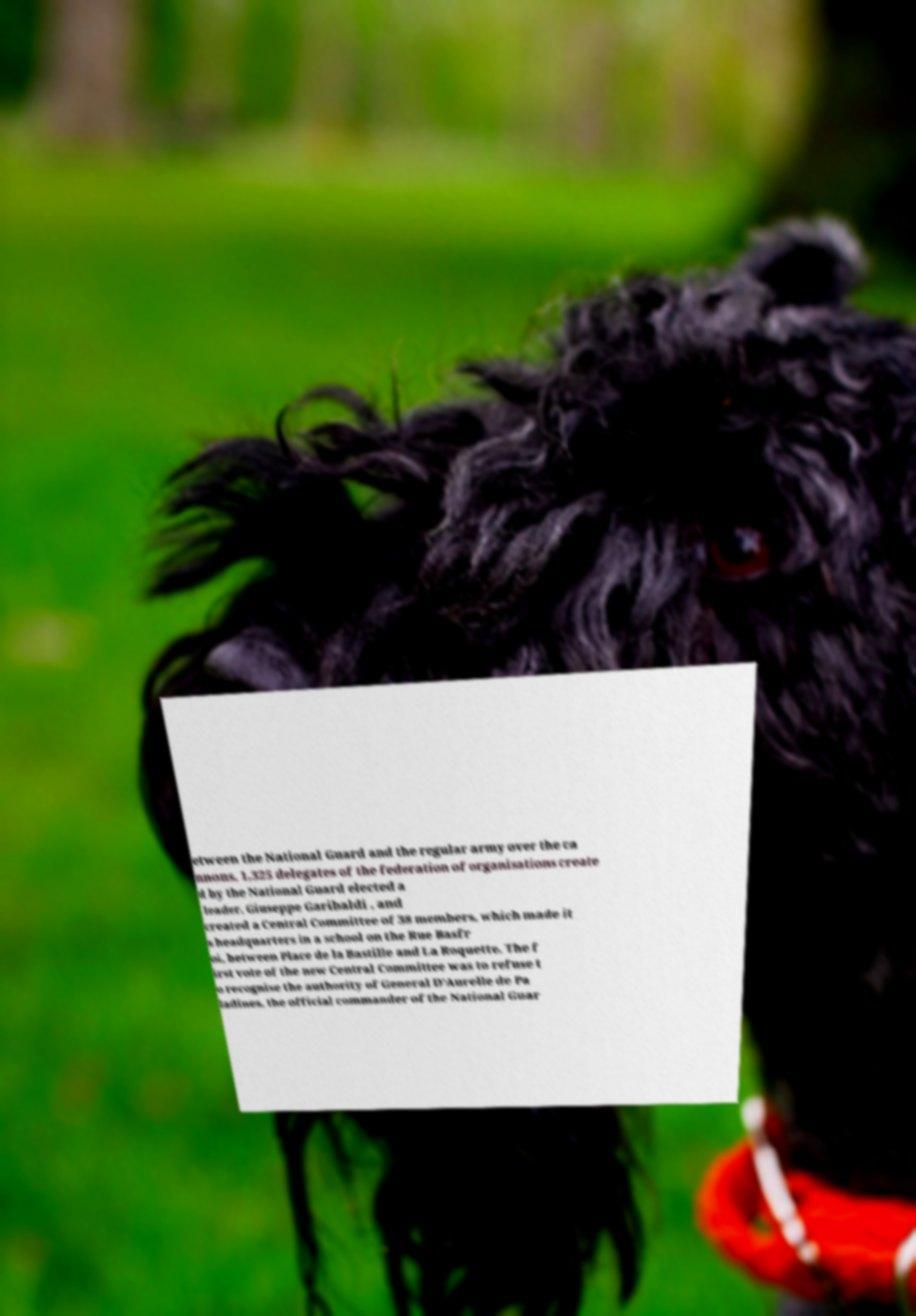Please identify and transcribe the text found in this image. etween the National Guard and the regular army over the ca nnons, 1,325 delegates of the federation of organisations create d by the National Guard elected a leader, Giuseppe Garibaldi , and created a Central Committee of 38 members, which made it s headquarters in a school on the Rue Basfr oi, between Place de la Bastille and La Roquette. The f irst vote of the new Central Committee was to refuse t o recognise the authority of General D'Aurelle de Pa ladines, the official commander of the National Guar 